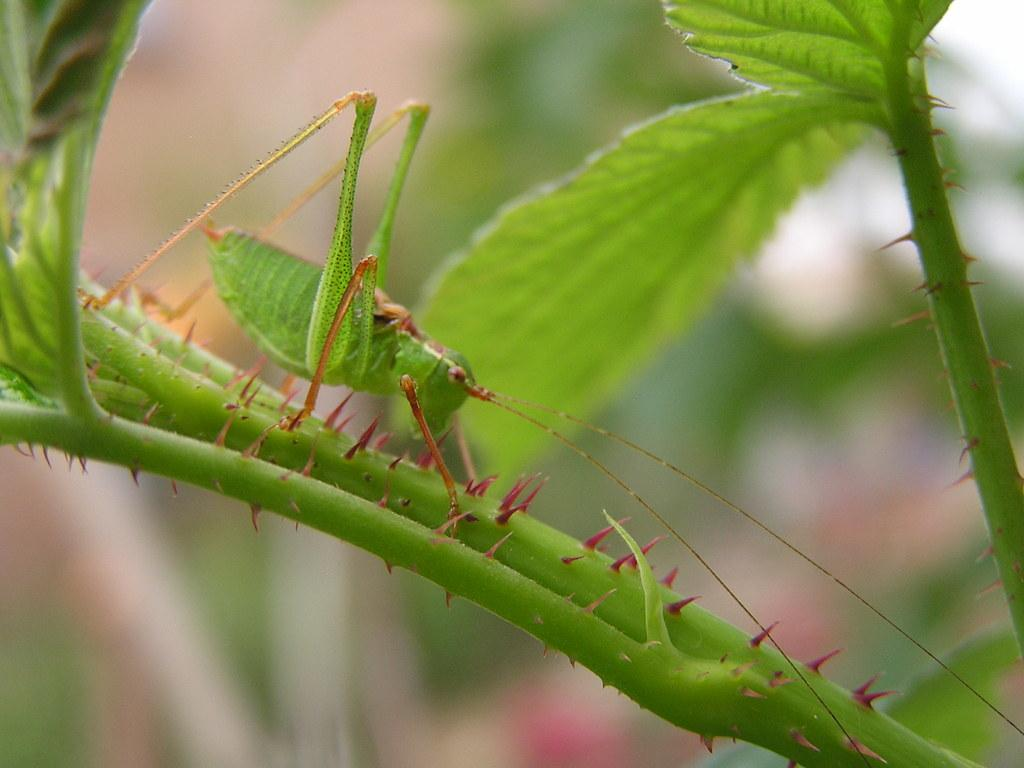What is the main subject of the picture? The main subject of the picture is an insect. Where is the insect located in the image? The insect is on a plant. What can be seen on the plant besides the insect? There are leaves visible in the picture. How would you describe the background of the image? The background of the image is blurry. How does the insect increase the speed of the airport in the image? There is no airport present in the image, and the insect does not have any influence on the speed of an airport. 